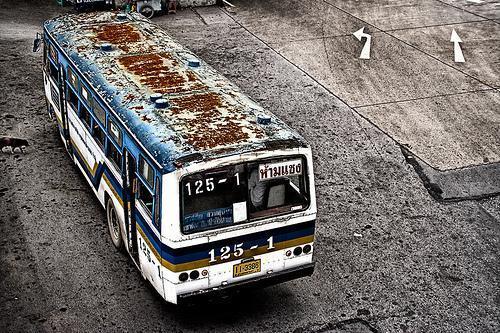How many arrows are showing?
Give a very brief answer. 2. How many buses are there in the picture?
Give a very brief answer. 1. How many animals are approaching the bus?
Give a very brief answer. 1. 